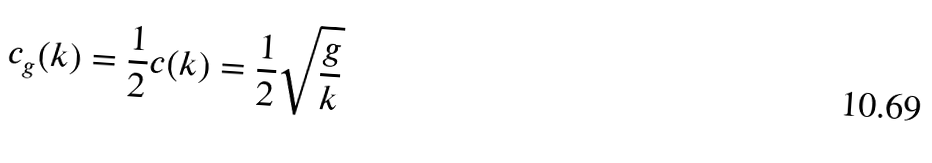<formula> <loc_0><loc_0><loc_500><loc_500>c _ { g } ( k ) = \frac { 1 } { 2 } c ( k ) = \frac { 1 } { 2 } \sqrt { \frac { g } { k } }</formula> 